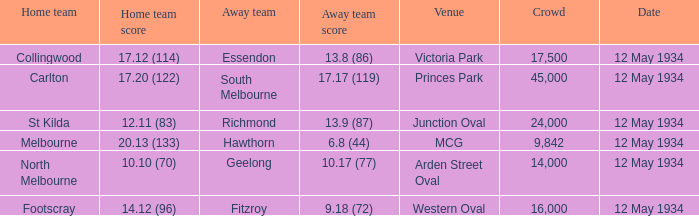What place had an Away team get a score of 10.17 (77)? Arden Street Oval. 